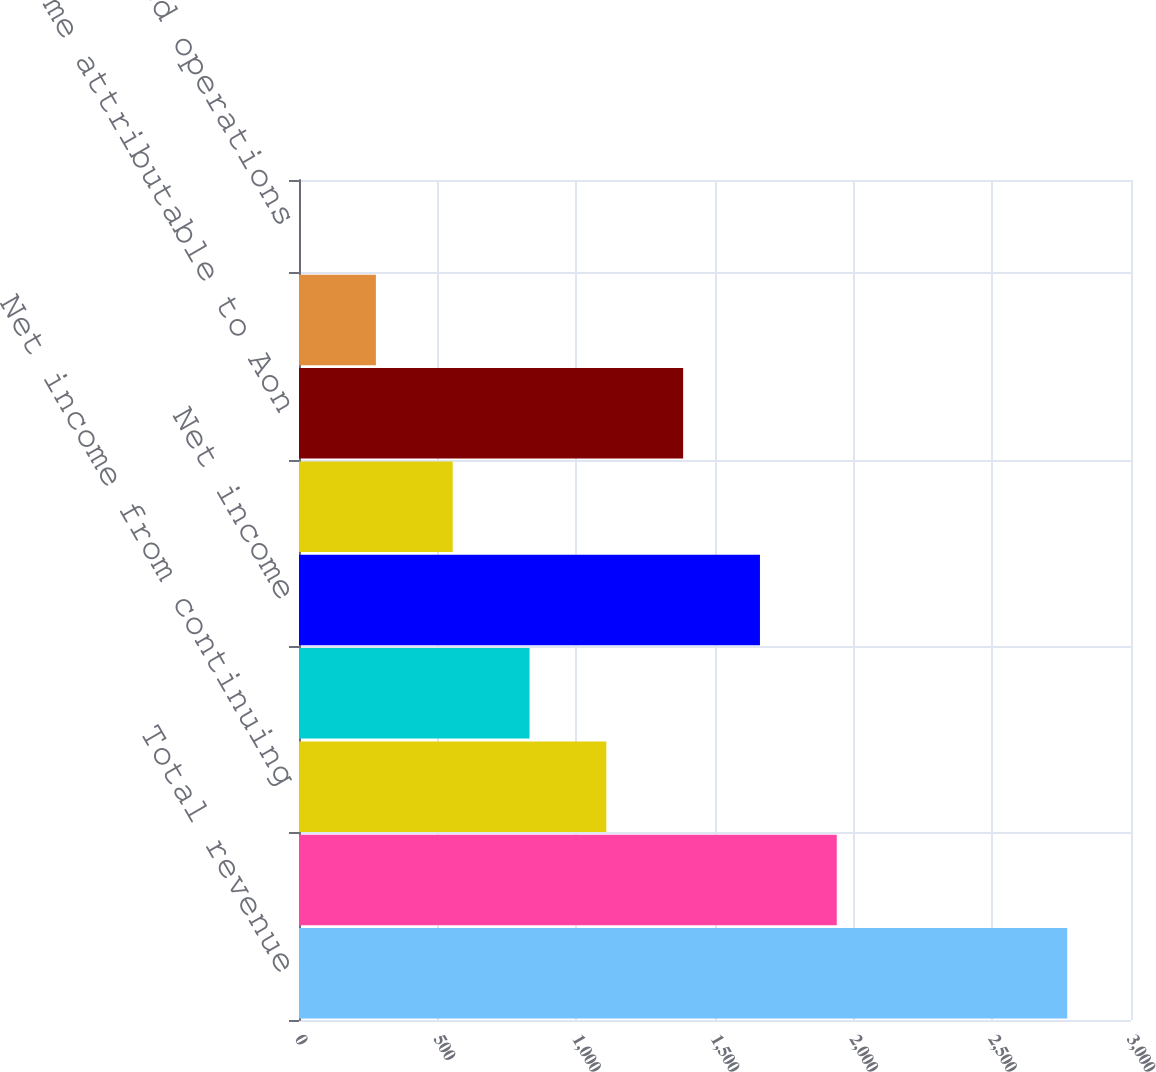Convert chart. <chart><loc_0><loc_0><loc_500><loc_500><bar_chart><fcel>Total revenue<fcel>Operating income<fcel>Net income from continuing<fcel>Income from discontinued<fcel>Net income<fcel>Less Net income attributable<fcel>Net income attributable to Aon<fcel>Continuing operations<fcel>Discontinued operations<nl><fcel>2770<fcel>1939.07<fcel>1108.16<fcel>831.19<fcel>1662.1<fcel>554.22<fcel>1385.13<fcel>277.25<fcel>0.28<nl></chart> 